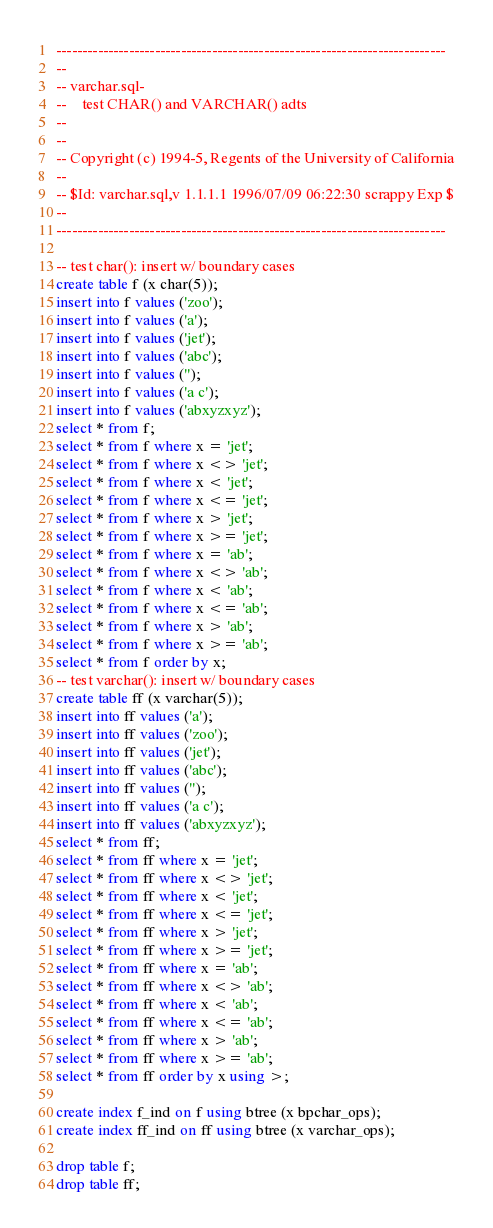<code> <loc_0><loc_0><loc_500><loc_500><_SQL_>---------------------------------------------------------------------------
--
-- varchar.sql-
--    test CHAR() and VARCHAR() adts
--
--
-- Copyright (c) 1994-5, Regents of the University of California
--
-- $Id: varchar.sql,v 1.1.1.1 1996/07/09 06:22:30 scrappy Exp $
--
---------------------------------------------------------------------------

-- test char(): insert w/ boundary cases
create table f (x char(5));
insert into f values ('zoo');
insert into f values ('a');
insert into f values ('jet');
insert into f values ('abc');
insert into f values ('');
insert into f values ('a c');
insert into f values ('abxyzxyz');
select * from f;
select * from f where x = 'jet';
select * from f where x <> 'jet';
select * from f where x < 'jet';
select * from f where x <= 'jet';
select * from f where x > 'jet';
select * from f where x >= 'jet';
select * from f where x = 'ab';
select * from f where x <> 'ab';
select * from f where x < 'ab';
select * from f where x <= 'ab';
select * from f where x > 'ab';
select * from f where x >= 'ab';
select * from f order by x;
-- test varchar(): insert w/ boundary cases
create table ff (x varchar(5));
insert into ff values ('a');
insert into ff values ('zoo');
insert into ff values ('jet');
insert into ff values ('abc');
insert into ff values ('');
insert into ff values ('a c');
insert into ff values ('abxyzxyz');
select * from ff;
select * from ff where x = 'jet';
select * from ff where x <> 'jet';
select * from ff where x < 'jet';
select * from ff where x <= 'jet';
select * from ff where x > 'jet';
select * from ff where x >= 'jet';
select * from ff where x = 'ab';
select * from ff where x <> 'ab';
select * from ff where x < 'ab';
select * from ff where x <= 'ab';
select * from ff where x > 'ab';
select * from ff where x >= 'ab';
select * from ff order by x using >;

create index f_ind on f using btree (x bpchar_ops);
create index ff_ind on ff using btree (x varchar_ops);

drop table f;
drop table ff;
</code> 